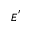<formula> <loc_0><loc_0><loc_500><loc_500>E ^ { ^ { \prime } }</formula> 